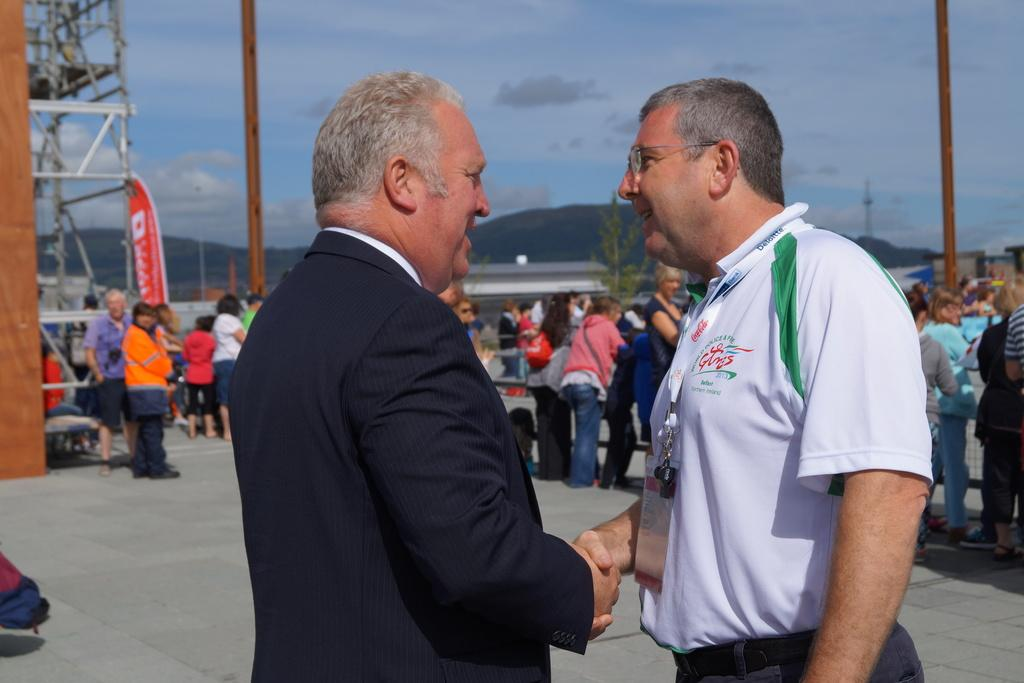What are the two persons in the image doing? The two persons in the image are standing and handshaking each other. What can be seen in the background of the image? There is a group of people standing in the background and hills visible in the background. What is visible at the top of the image? The sky is visible in the image. How many rabbits can be seen pulling the bushes in the image? There are no rabbits or bushes present in the image. 